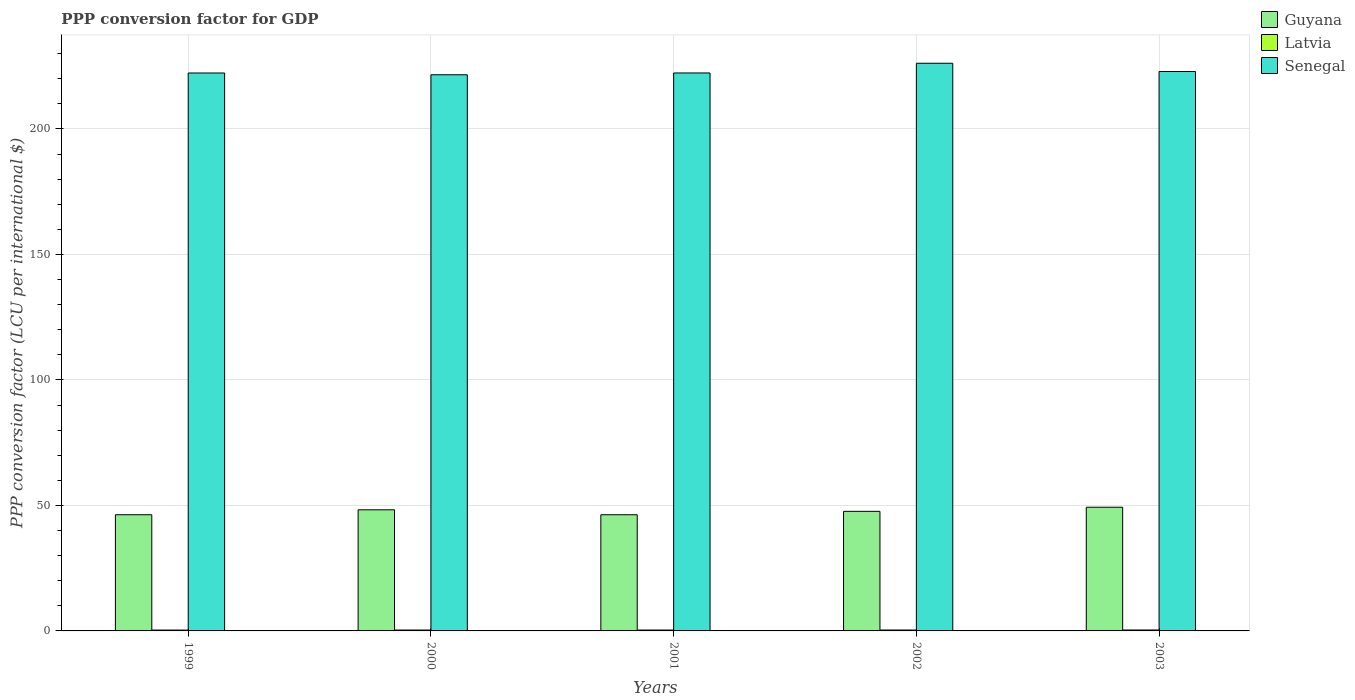How many different coloured bars are there?
Ensure brevity in your answer.  3. How many bars are there on the 2nd tick from the left?
Your answer should be compact. 3. How many bars are there on the 4th tick from the right?
Offer a very short reply. 3. What is the PPP conversion factor for GDP in Latvia in 1999?
Offer a very short reply. 0.34. Across all years, what is the maximum PPP conversion factor for GDP in Guyana?
Make the answer very short. 49.27. Across all years, what is the minimum PPP conversion factor for GDP in Latvia?
Provide a succinct answer. 0.34. In which year was the PPP conversion factor for GDP in Latvia maximum?
Ensure brevity in your answer.  2003. In which year was the PPP conversion factor for GDP in Latvia minimum?
Keep it short and to the point. 1999. What is the total PPP conversion factor for GDP in Senegal in the graph?
Keep it short and to the point. 1115.2. What is the difference between the PPP conversion factor for GDP in Senegal in 1999 and that in 2003?
Offer a terse response. -0.59. What is the difference between the PPP conversion factor for GDP in Latvia in 2001 and the PPP conversion factor for GDP in Guyana in 1999?
Offer a terse response. -45.94. What is the average PPP conversion factor for GDP in Guyana per year?
Keep it short and to the point. 47.55. In the year 2000, what is the difference between the PPP conversion factor for GDP in Senegal and PPP conversion factor for GDP in Latvia?
Provide a succinct answer. 221.22. What is the ratio of the PPP conversion factor for GDP in Latvia in 2002 to that in 2003?
Keep it short and to the point. 0.97. Is the PPP conversion factor for GDP in Guyana in 2001 less than that in 2002?
Your answer should be compact. Yes. What is the difference between the highest and the second highest PPP conversion factor for GDP in Senegal?
Provide a succinct answer. 3.29. What is the difference between the highest and the lowest PPP conversion factor for GDP in Guyana?
Provide a short and direct response. 2.99. What does the 2nd bar from the left in 2003 represents?
Your answer should be compact. Latvia. What does the 3rd bar from the right in 1999 represents?
Your response must be concise. Guyana. Is it the case that in every year, the sum of the PPP conversion factor for GDP in Latvia and PPP conversion factor for GDP in Guyana is greater than the PPP conversion factor for GDP in Senegal?
Keep it short and to the point. No. How many bars are there?
Ensure brevity in your answer.  15. What is the difference between two consecutive major ticks on the Y-axis?
Make the answer very short. 50. Does the graph contain any zero values?
Provide a short and direct response. No. Does the graph contain grids?
Your response must be concise. Yes. Where does the legend appear in the graph?
Give a very brief answer. Top right. How many legend labels are there?
Ensure brevity in your answer.  3. What is the title of the graph?
Your response must be concise. PPP conversion factor for GDP. Does "Sudan" appear as one of the legend labels in the graph?
Your answer should be compact. No. What is the label or title of the X-axis?
Make the answer very short. Years. What is the label or title of the Y-axis?
Keep it short and to the point. PPP conversion factor (LCU per international $). What is the PPP conversion factor (LCU per international $) in Guyana in 1999?
Offer a very short reply. 46.29. What is the PPP conversion factor (LCU per international $) in Latvia in 1999?
Your answer should be compact. 0.34. What is the PPP conversion factor (LCU per international $) in Senegal in 1999?
Your answer should be very brief. 222.29. What is the PPP conversion factor (LCU per international $) in Guyana in 2000?
Ensure brevity in your answer.  48.25. What is the PPP conversion factor (LCU per international $) in Latvia in 2000?
Keep it short and to the point. 0.35. What is the PPP conversion factor (LCU per international $) in Senegal in 2000?
Provide a short and direct response. 221.57. What is the PPP conversion factor (LCU per international $) of Guyana in 2001?
Provide a short and direct response. 46.29. What is the PPP conversion factor (LCU per international $) in Latvia in 2001?
Offer a very short reply. 0.35. What is the PPP conversion factor (LCU per international $) of Senegal in 2001?
Offer a very short reply. 222.3. What is the PPP conversion factor (LCU per international $) of Guyana in 2002?
Offer a terse response. 47.64. What is the PPP conversion factor (LCU per international $) in Latvia in 2002?
Offer a terse response. 0.36. What is the PPP conversion factor (LCU per international $) in Senegal in 2002?
Your answer should be compact. 226.16. What is the PPP conversion factor (LCU per international $) in Guyana in 2003?
Offer a very short reply. 49.27. What is the PPP conversion factor (LCU per international $) in Latvia in 2003?
Provide a succinct answer. 0.37. What is the PPP conversion factor (LCU per international $) of Senegal in 2003?
Ensure brevity in your answer.  222.88. Across all years, what is the maximum PPP conversion factor (LCU per international $) of Guyana?
Offer a very short reply. 49.27. Across all years, what is the maximum PPP conversion factor (LCU per international $) of Latvia?
Offer a very short reply. 0.37. Across all years, what is the maximum PPP conversion factor (LCU per international $) in Senegal?
Ensure brevity in your answer.  226.16. Across all years, what is the minimum PPP conversion factor (LCU per international $) in Guyana?
Your response must be concise. 46.29. Across all years, what is the minimum PPP conversion factor (LCU per international $) in Latvia?
Your answer should be very brief. 0.34. Across all years, what is the minimum PPP conversion factor (LCU per international $) of Senegal?
Make the answer very short. 221.57. What is the total PPP conversion factor (LCU per international $) of Guyana in the graph?
Provide a succinct answer. 237.75. What is the total PPP conversion factor (LCU per international $) in Latvia in the graph?
Ensure brevity in your answer.  1.77. What is the total PPP conversion factor (LCU per international $) of Senegal in the graph?
Provide a succinct answer. 1115.2. What is the difference between the PPP conversion factor (LCU per international $) of Guyana in 1999 and that in 2000?
Give a very brief answer. -1.96. What is the difference between the PPP conversion factor (LCU per international $) in Latvia in 1999 and that in 2000?
Your answer should be very brief. -0.01. What is the difference between the PPP conversion factor (LCU per international $) of Senegal in 1999 and that in 2000?
Your response must be concise. 0.71. What is the difference between the PPP conversion factor (LCU per international $) of Guyana in 1999 and that in 2001?
Offer a very short reply. 0.01. What is the difference between the PPP conversion factor (LCU per international $) in Latvia in 1999 and that in 2001?
Your answer should be compact. -0.01. What is the difference between the PPP conversion factor (LCU per international $) in Senegal in 1999 and that in 2001?
Offer a terse response. -0.01. What is the difference between the PPP conversion factor (LCU per international $) in Guyana in 1999 and that in 2002?
Provide a short and direct response. -1.35. What is the difference between the PPP conversion factor (LCU per international $) in Latvia in 1999 and that in 2002?
Offer a very short reply. -0.01. What is the difference between the PPP conversion factor (LCU per international $) of Senegal in 1999 and that in 2002?
Give a very brief answer. -3.88. What is the difference between the PPP conversion factor (LCU per international $) of Guyana in 1999 and that in 2003?
Offer a very short reply. -2.98. What is the difference between the PPP conversion factor (LCU per international $) of Latvia in 1999 and that in 2003?
Provide a short and direct response. -0.03. What is the difference between the PPP conversion factor (LCU per international $) of Senegal in 1999 and that in 2003?
Provide a short and direct response. -0.59. What is the difference between the PPP conversion factor (LCU per international $) in Guyana in 2000 and that in 2001?
Your answer should be very brief. 1.97. What is the difference between the PPP conversion factor (LCU per international $) of Latvia in 2000 and that in 2001?
Offer a very short reply. 0. What is the difference between the PPP conversion factor (LCU per international $) in Senegal in 2000 and that in 2001?
Offer a terse response. -0.73. What is the difference between the PPP conversion factor (LCU per international $) in Guyana in 2000 and that in 2002?
Offer a very short reply. 0.61. What is the difference between the PPP conversion factor (LCU per international $) of Latvia in 2000 and that in 2002?
Ensure brevity in your answer.  -0. What is the difference between the PPP conversion factor (LCU per international $) of Senegal in 2000 and that in 2002?
Offer a terse response. -4.59. What is the difference between the PPP conversion factor (LCU per international $) of Guyana in 2000 and that in 2003?
Provide a succinct answer. -1.02. What is the difference between the PPP conversion factor (LCU per international $) of Latvia in 2000 and that in 2003?
Your response must be concise. -0.01. What is the difference between the PPP conversion factor (LCU per international $) of Senegal in 2000 and that in 2003?
Offer a very short reply. -1.3. What is the difference between the PPP conversion factor (LCU per international $) in Guyana in 2001 and that in 2002?
Keep it short and to the point. -1.36. What is the difference between the PPP conversion factor (LCU per international $) in Latvia in 2001 and that in 2002?
Your answer should be very brief. -0. What is the difference between the PPP conversion factor (LCU per international $) in Senegal in 2001 and that in 2002?
Your response must be concise. -3.86. What is the difference between the PPP conversion factor (LCU per international $) of Guyana in 2001 and that in 2003?
Provide a succinct answer. -2.99. What is the difference between the PPP conversion factor (LCU per international $) of Latvia in 2001 and that in 2003?
Ensure brevity in your answer.  -0.01. What is the difference between the PPP conversion factor (LCU per international $) in Senegal in 2001 and that in 2003?
Offer a very short reply. -0.58. What is the difference between the PPP conversion factor (LCU per international $) in Guyana in 2002 and that in 2003?
Make the answer very short. -1.63. What is the difference between the PPP conversion factor (LCU per international $) of Latvia in 2002 and that in 2003?
Your response must be concise. -0.01. What is the difference between the PPP conversion factor (LCU per international $) of Senegal in 2002 and that in 2003?
Keep it short and to the point. 3.29. What is the difference between the PPP conversion factor (LCU per international $) of Guyana in 1999 and the PPP conversion factor (LCU per international $) of Latvia in 2000?
Provide a succinct answer. 45.94. What is the difference between the PPP conversion factor (LCU per international $) of Guyana in 1999 and the PPP conversion factor (LCU per international $) of Senegal in 2000?
Your answer should be very brief. -175.28. What is the difference between the PPP conversion factor (LCU per international $) of Latvia in 1999 and the PPP conversion factor (LCU per international $) of Senegal in 2000?
Your response must be concise. -221.23. What is the difference between the PPP conversion factor (LCU per international $) of Guyana in 1999 and the PPP conversion factor (LCU per international $) of Latvia in 2001?
Make the answer very short. 45.94. What is the difference between the PPP conversion factor (LCU per international $) in Guyana in 1999 and the PPP conversion factor (LCU per international $) in Senegal in 2001?
Offer a very short reply. -176.01. What is the difference between the PPP conversion factor (LCU per international $) in Latvia in 1999 and the PPP conversion factor (LCU per international $) in Senegal in 2001?
Make the answer very short. -221.96. What is the difference between the PPP conversion factor (LCU per international $) of Guyana in 1999 and the PPP conversion factor (LCU per international $) of Latvia in 2002?
Provide a succinct answer. 45.94. What is the difference between the PPP conversion factor (LCU per international $) in Guyana in 1999 and the PPP conversion factor (LCU per international $) in Senegal in 2002?
Make the answer very short. -179.87. What is the difference between the PPP conversion factor (LCU per international $) in Latvia in 1999 and the PPP conversion factor (LCU per international $) in Senegal in 2002?
Ensure brevity in your answer.  -225.82. What is the difference between the PPP conversion factor (LCU per international $) of Guyana in 1999 and the PPP conversion factor (LCU per international $) of Latvia in 2003?
Give a very brief answer. 45.93. What is the difference between the PPP conversion factor (LCU per international $) in Guyana in 1999 and the PPP conversion factor (LCU per international $) in Senegal in 2003?
Offer a terse response. -176.58. What is the difference between the PPP conversion factor (LCU per international $) in Latvia in 1999 and the PPP conversion factor (LCU per international $) in Senegal in 2003?
Offer a terse response. -222.54. What is the difference between the PPP conversion factor (LCU per international $) of Guyana in 2000 and the PPP conversion factor (LCU per international $) of Latvia in 2001?
Provide a succinct answer. 47.9. What is the difference between the PPP conversion factor (LCU per international $) in Guyana in 2000 and the PPP conversion factor (LCU per international $) in Senegal in 2001?
Offer a very short reply. -174.05. What is the difference between the PPP conversion factor (LCU per international $) of Latvia in 2000 and the PPP conversion factor (LCU per international $) of Senegal in 2001?
Make the answer very short. -221.94. What is the difference between the PPP conversion factor (LCU per international $) in Guyana in 2000 and the PPP conversion factor (LCU per international $) in Latvia in 2002?
Offer a very short reply. 47.9. What is the difference between the PPP conversion factor (LCU per international $) in Guyana in 2000 and the PPP conversion factor (LCU per international $) in Senegal in 2002?
Provide a short and direct response. -177.91. What is the difference between the PPP conversion factor (LCU per international $) in Latvia in 2000 and the PPP conversion factor (LCU per international $) in Senegal in 2002?
Your answer should be very brief. -225.81. What is the difference between the PPP conversion factor (LCU per international $) in Guyana in 2000 and the PPP conversion factor (LCU per international $) in Latvia in 2003?
Keep it short and to the point. 47.88. What is the difference between the PPP conversion factor (LCU per international $) in Guyana in 2000 and the PPP conversion factor (LCU per international $) in Senegal in 2003?
Provide a short and direct response. -174.63. What is the difference between the PPP conversion factor (LCU per international $) of Latvia in 2000 and the PPP conversion factor (LCU per international $) of Senegal in 2003?
Your answer should be very brief. -222.52. What is the difference between the PPP conversion factor (LCU per international $) of Guyana in 2001 and the PPP conversion factor (LCU per international $) of Latvia in 2002?
Keep it short and to the point. 45.93. What is the difference between the PPP conversion factor (LCU per international $) of Guyana in 2001 and the PPP conversion factor (LCU per international $) of Senegal in 2002?
Give a very brief answer. -179.88. What is the difference between the PPP conversion factor (LCU per international $) in Latvia in 2001 and the PPP conversion factor (LCU per international $) in Senegal in 2002?
Make the answer very short. -225.81. What is the difference between the PPP conversion factor (LCU per international $) of Guyana in 2001 and the PPP conversion factor (LCU per international $) of Latvia in 2003?
Offer a terse response. 45.92. What is the difference between the PPP conversion factor (LCU per international $) of Guyana in 2001 and the PPP conversion factor (LCU per international $) of Senegal in 2003?
Ensure brevity in your answer.  -176.59. What is the difference between the PPP conversion factor (LCU per international $) in Latvia in 2001 and the PPP conversion factor (LCU per international $) in Senegal in 2003?
Your answer should be compact. -222.52. What is the difference between the PPP conversion factor (LCU per international $) in Guyana in 2002 and the PPP conversion factor (LCU per international $) in Latvia in 2003?
Your answer should be compact. 47.28. What is the difference between the PPP conversion factor (LCU per international $) of Guyana in 2002 and the PPP conversion factor (LCU per international $) of Senegal in 2003?
Your answer should be compact. -175.23. What is the difference between the PPP conversion factor (LCU per international $) of Latvia in 2002 and the PPP conversion factor (LCU per international $) of Senegal in 2003?
Offer a very short reply. -222.52. What is the average PPP conversion factor (LCU per international $) in Guyana per year?
Make the answer very short. 47.55. What is the average PPP conversion factor (LCU per international $) in Latvia per year?
Keep it short and to the point. 0.35. What is the average PPP conversion factor (LCU per international $) of Senegal per year?
Provide a short and direct response. 223.04. In the year 1999, what is the difference between the PPP conversion factor (LCU per international $) of Guyana and PPP conversion factor (LCU per international $) of Latvia?
Your answer should be compact. 45.95. In the year 1999, what is the difference between the PPP conversion factor (LCU per international $) of Guyana and PPP conversion factor (LCU per international $) of Senegal?
Your answer should be compact. -175.99. In the year 1999, what is the difference between the PPP conversion factor (LCU per international $) of Latvia and PPP conversion factor (LCU per international $) of Senegal?
Provide a short and direct response. -221.94. In the year 2000, what is the difference between the PPP conversion factor (LCU per international $) of Guyana and PPP conversion factor (LCU per international $) of Latvia?
Offer a very short reply. 47.9. In the year 2000, what is the difference between the PPP conversion factor (LCU per international $) in Guyana and PPP conversion factor (LCU per international $) in Senegal?
Provide a succinct answer. -173.32. In the year 2000, what is the difference between the PPP conversion factor (LCU per international $) of Latvia and PPP conversion factor (LCU per international $) of Senegal?
Provide a succinct answer. -221.22. In the year 2001, what is the difference between the PPP conversion factor (LCU per international $) of Guyana and PPP conversion factor (LCU per international $) of Latvia?
Your response must be concise. 45.93. In the year 2001, what is the difference between the PPP conversion factor (LCU per international $) in Guyana and PPP conversion factor (LCU per international $) in Senegal?
Your answer should be compact. -176.01. In the year 2001, what is the difference between the PPP conversion factor (LCU per international $) in Latvia and PPP conversion factor (LCU per international $) in Senegal?
Give a very brief answer. -221.95. In the year 2002, what is the difference between the PPP conversion factor (LCU per international $) in Guyana and PPP conversion factor (LCU per international $) in Latvia?
Ensure brevity in your answer.  47.29. In the year 2002, what is the difference between the PPP conversion factor (LCU per international $) of Guyana and PPP conversion factor (LCU per international $) of Senegal?
Provide a short and direct response. -178.52. In the year 2002, what is the difference between the PPP conversion factor (LCU per international $) of Latvia and PPP conversion factor (LCU per international $) of Senegal?
Offer a terse response. -225.81. In the year 2003, what is the difference between the PPP conversion factor (LCU per international $) in Guyana and PPP conversion factor (LCU per international $) in Latvia?
Give a very brief answer. 48.91. In the year 2003, what is the difference between the PPP conversion factor (LCU per international $) in Guyana and PPP conversion factor (LCU per international $) in Senegal?
Keep it short and to the point. -173.6. In the year 2003, what is the difference between the PPP conversion factor (LCU per international $) of Latvia and PPP conversion factor (LCU per international $) of Senegal?
Your answer should be compact. -222.51. What is the ratio of the PPP conversion factor (LCU per international $) of Guyana in 1999 to that in 2000?
Provide a succinct answer. 0.96. What is the ratio of the PPP conversion factor (LCU per international $) of Latvia in 1999 to that in 2000?
Ensure brevity in your answer.  0.97. What is the ratio of the PPP conversion factor (LCU per international $) of Senegal in 1999 to that in 2000?
Your response must be concise. 1. What is the ratio of the PPP conversion factor (LCU per international $) in Guyana in 1999 to that in 2001?
Your response must be concise. 1. What is the ratio of the PPP conversion factor (LCU per international $) in Latvia in 1999 to that in 2001?
Provide a succinct answer. 0.97. What is the ratio of the PPP conversion factor (LCU per international $) of Senegal in 1999 to that in 2001?
Your answer should be compact. 1. What is the ratio of the PPP conversion factor (LCU per international $) in Guyana in 1999 to that in 2002?
Offer a very short reply. 0.97. What is the ratio of the PPP conversion factor (LCU per international $) of Latvia in 1999 to that in 2002?
Keep it short and to the point. 0.96. What is the ratio of the PPP conversion factor (LCU per international $) in Senegal in 1999 to that in 2002?
Ensure brevity in your answer.  0.98. What is the ratio of the PPP conversion factor (LCU per international $) in Guyana in 1999 to that in 2003?
Keep it short and to the point. 0.94. What is the ratio of the PPP conversion factor (LCU per international $) in Latvia in 1999 to that in 2003?
Your response must be concise. 0.93. What is the ratio of the PPP conversion factor (LCU per international $) of Guyana in 2000 to that in 2001?
Offer a terse response. 1.04. What is the ratio of the PPP conversion factor (LCU per international $) of Latvia in 2000 to that in 2001?
Your answer should be very brief. 1. What is the ratio of the PPP conversion factor (LCU per international $) of Guyana in 2000 to that in 2002?
Give a very brief answer. 1.01. What is the ratio of the PPP conversion factor (LCU per international $) of Latvia in 2000 to that in 2002?
Offer a terse response. 1. What is the ratio of the PPP conversion factor (LCU per international $) in Senegal in 2000 to that in 2002?
Give a very brief answer. 0.98. What is the ratio of the PPP conversion factor (LCU per international $) in Guyana in 2000 to that in 2003?
Your answer should be compact. 0.98. What is the ratio of the PPP conversion factor (LCU per international $) of Latvia in 2000 to that in 2003?
Your answer should be very brief. 0.96. What is the ratio of the PPP conversion factor (LCU per international $) of Senegal in 2000 to that in 2003?
Offer a terse response. 0.99. What is the ratio of the PPP conversion factor (LCU per international $) in Guyana in 2001 to that in 2002?
Your response must be concise. 0.97. What is the ratio of the PPP conversion factor (LCU per international $) of Latvia in 2001 to that in 2002?
Offer a terse response. 1. What is the ratio of the PPP conversion factor (LCU per international $) of Senegal in 2001 to that in 2002?
Offer a terse response. 0.98. What is the ratio of the PPP conversion factor (LCU per international $) of Guyana in 2001 to that in 2003?
Your response must be concise. 0.94. What is the ratio of the PPP conversion factor (LCU per international $) of Latvia in 2001 to that in 2003?
Provide a succinct answer. 0.96. What is the ratio of the PPP conversion factor (LCU per international $) of Guyana in 2002 to that in 2003?
Offer a very short reply. 0.97. What is the ratio of the PPP conversion factor (LCU per international $) in Latvia in 2002 to that in 2003?
Your answer should be very brief. 0.97. What is the ratio of the PPP conversion factor (LCU per international $) of Senegal in 2002 to that in 2003?
Your answer should be compact. 1.01. What is the difference between the highest and the second highest PPP conversion factor (LCU per international $) in Guyana?
Your response must be concise. 1.02. What is the difference between the highest and the second highest PPP conversion factor (LCU per international $) of Latvia?
Provide a succinct answer. 0.01. What is the difference between the highest and the second highest PPP conversion factor (LCU per international $) in Senegal?
Offer a terse response. 3.29. What is the difference between the highest and the lowest PPP conversion factor (LCU per international $) in Guyana?
Your response must be concise. 2.99. What is the difference between the highest and the lowest PPP conversion factor (LCU per international $) of Latvia?
Keep it short and to the point. 0.03. What is the difference between the highest and the lowest PPP conversion factor (LCU per international $) in Senegal?
Provide a short and direct response. 4.59. 